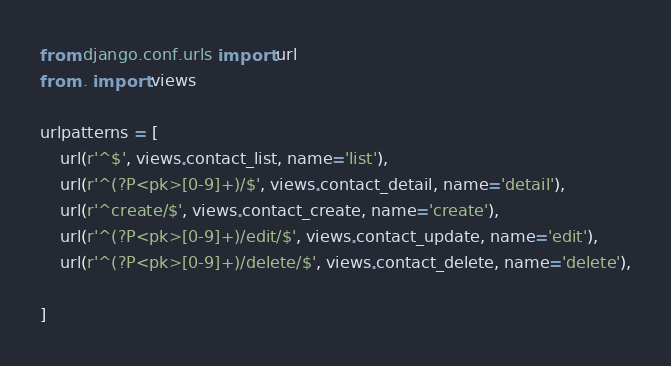Convert code to text. <code><loc_0><loc_0><loc_500><loc_500><_Python_>from django.conf.urls import url
from . import views

urlpatterns = [
    url(r'^$', views.contact_list, name='list'),
    url(r'^(?P<pk>[0-9]+)/$', views.contact_detail, name='detail'),
    url(r'^create/$', views.contact_create, name='create'),
    url(r'^(?P<pk>[0-9]+)/edit/$', views.contact_update, name='edit'),
    url(r'^(?P<pk>[0-9]+)/delete/$', views.contact_delete, name='delete'),

]
</code> 